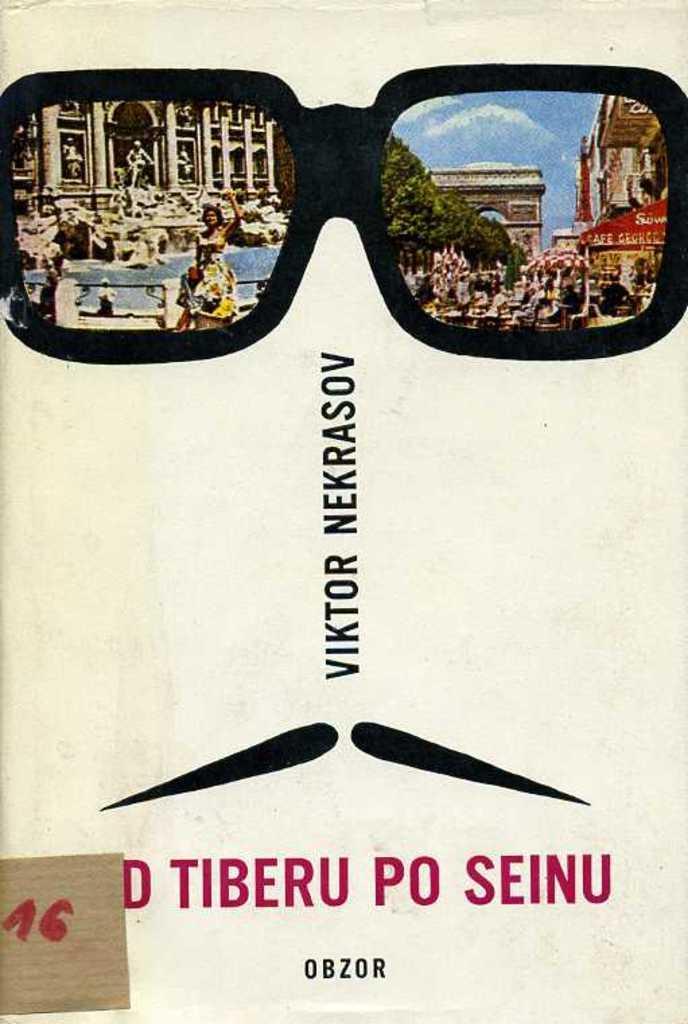How would you summarize this image in a sentence or two? This picture is consists of Bernard cribbins in the image. 